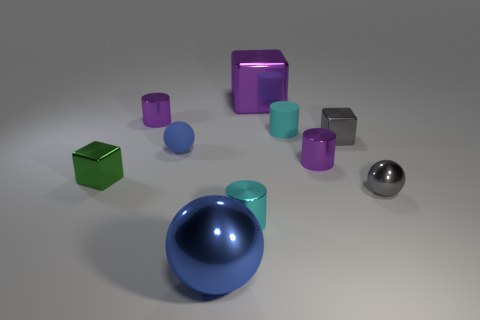Subtract 1 cylinders. How many cylinders are left? 3 Subtract all spheres. How many objects are left? 7 Subtract 0 red spheres. How many objects are left? 10 Subtract all blue metal cylinders. Subtract all metallic balls. How many objects are left? 8 Add 2 small gray objects. How many small gray objects are left? 4 Add 8 blue rubber cylinders. How many blue rubber cylinders exist? 8 